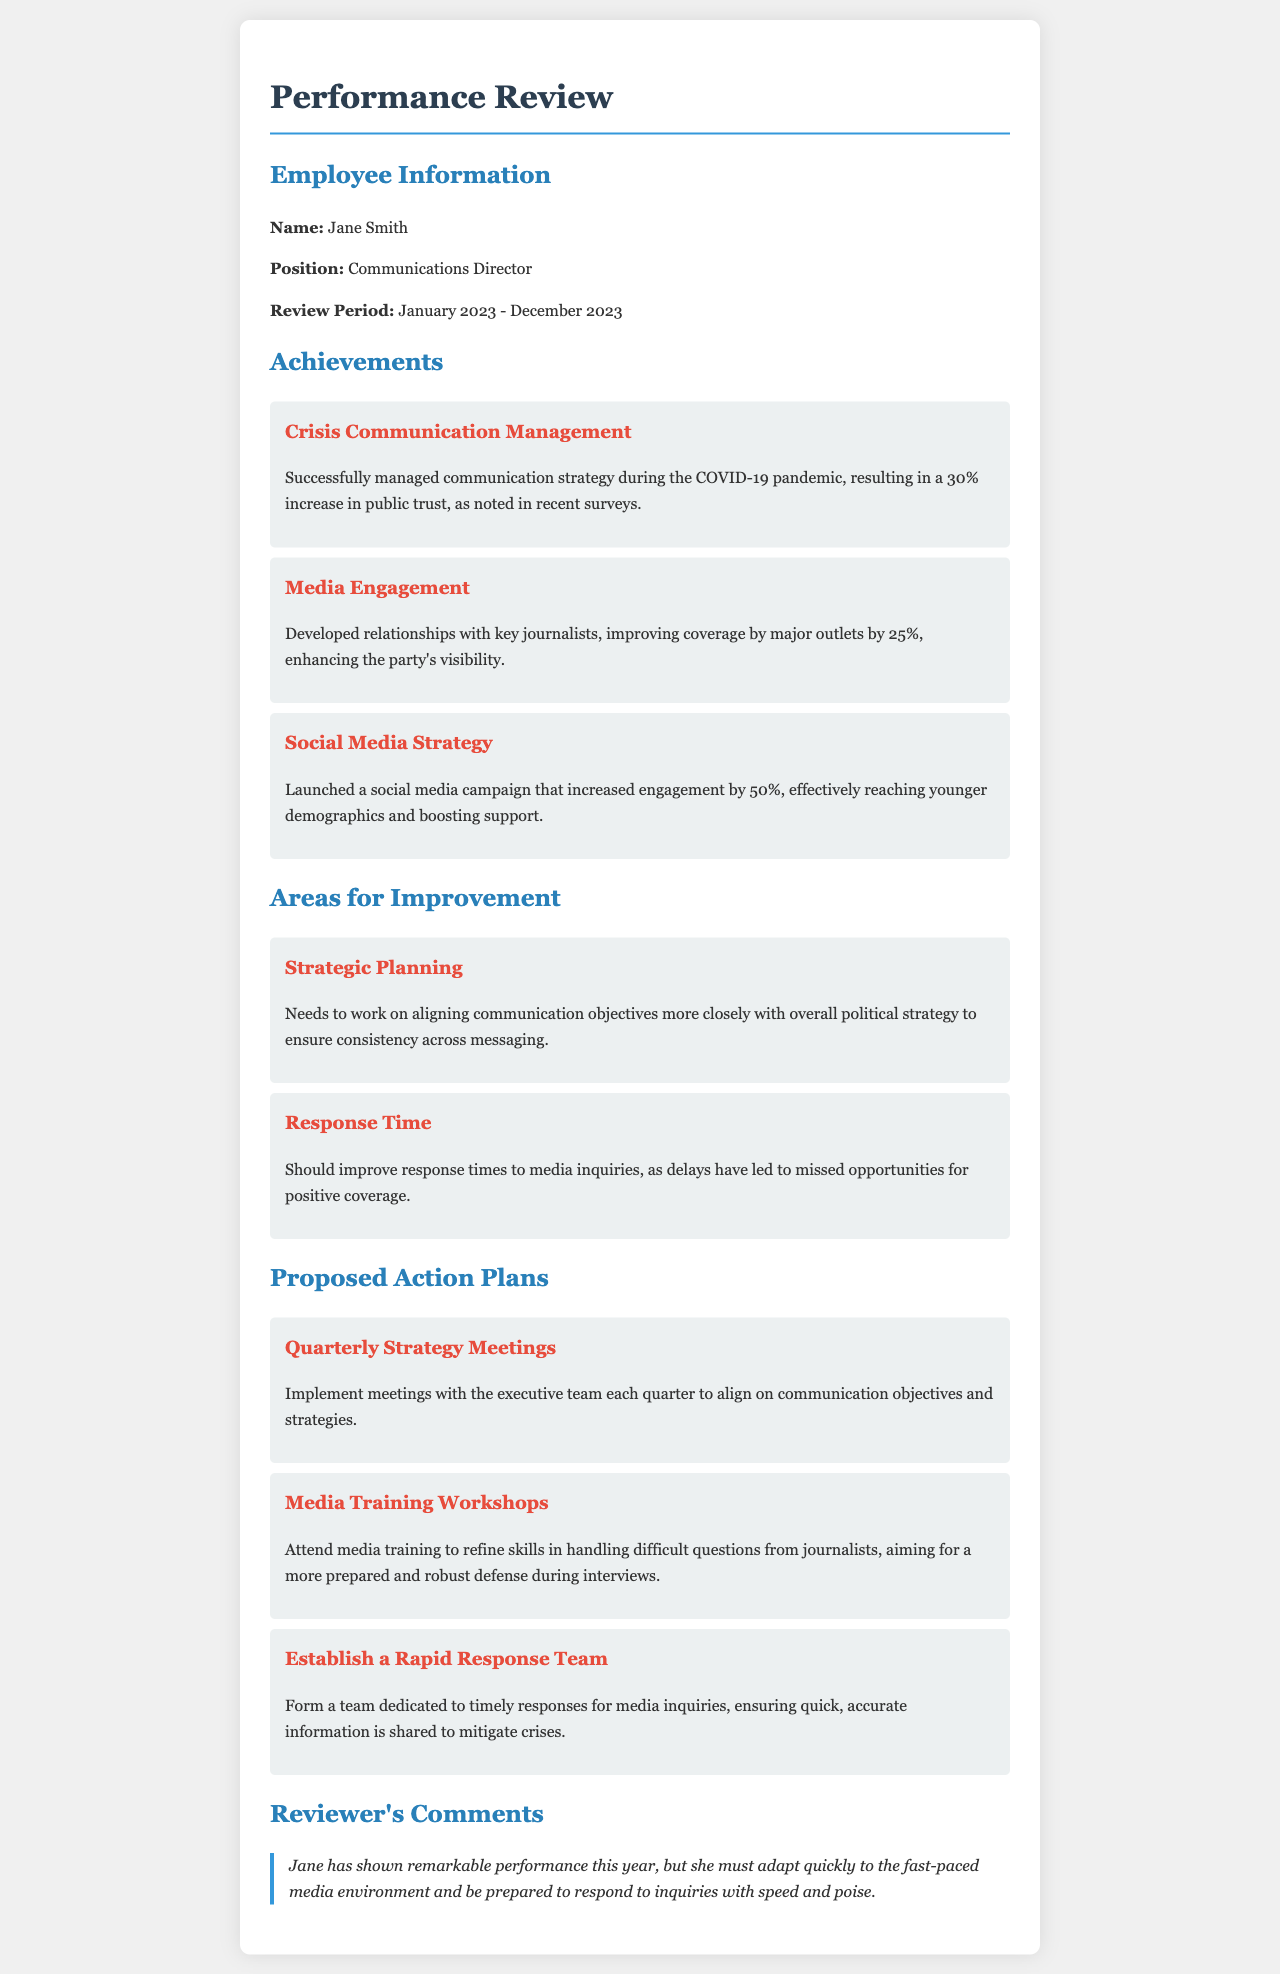What is the name of the employee? The document states the name of the employee in the Employee Information section, which is Jane Smith.
Answer: Jane Smith What is the position of Jane Smith? The position is listed in the Employee Information section of the document as Communications Director.
Answer: Communications Director What is the review period mentioned in the document? The review period is specified in the Employee Information section from January 2023 to December 2023.
Answer: January 2023 - December 2023 How much did public trust increase during the crisis communication management? The document mentions a specific percentage increase in public trust due to the communication strategy, which is 30%.
Answer: 30% What area for improvement relates to communication objectives? The document identifies Strategic Planning as an area that needs improvement related to aligning communication objectives.
Answer: Strategic Planning What is one proposed action plan for improving media response? The document presents several action plans, one of which includes forming a Rapid Response Team to ensure timely responses to media inquiries.
Answer: Establish a Rapid Response Team How much did media coverage improve by major outlets? The document indicates a specific improvement percentage in media coverage, which is 25%.
Answer: 25% What is one suggested training for Jane Smith? The document suggests attending Media Training Workshops to refine skills in an area crucial for her role.
Answer: Media Training Workshops What is the reviewer's overall comment on Jane's performance? The reviewer comments that Jane has shown remarkable performance but emphasizes the need for adaptability to the fast-paced media environment.
Answer: Remarkable performance 